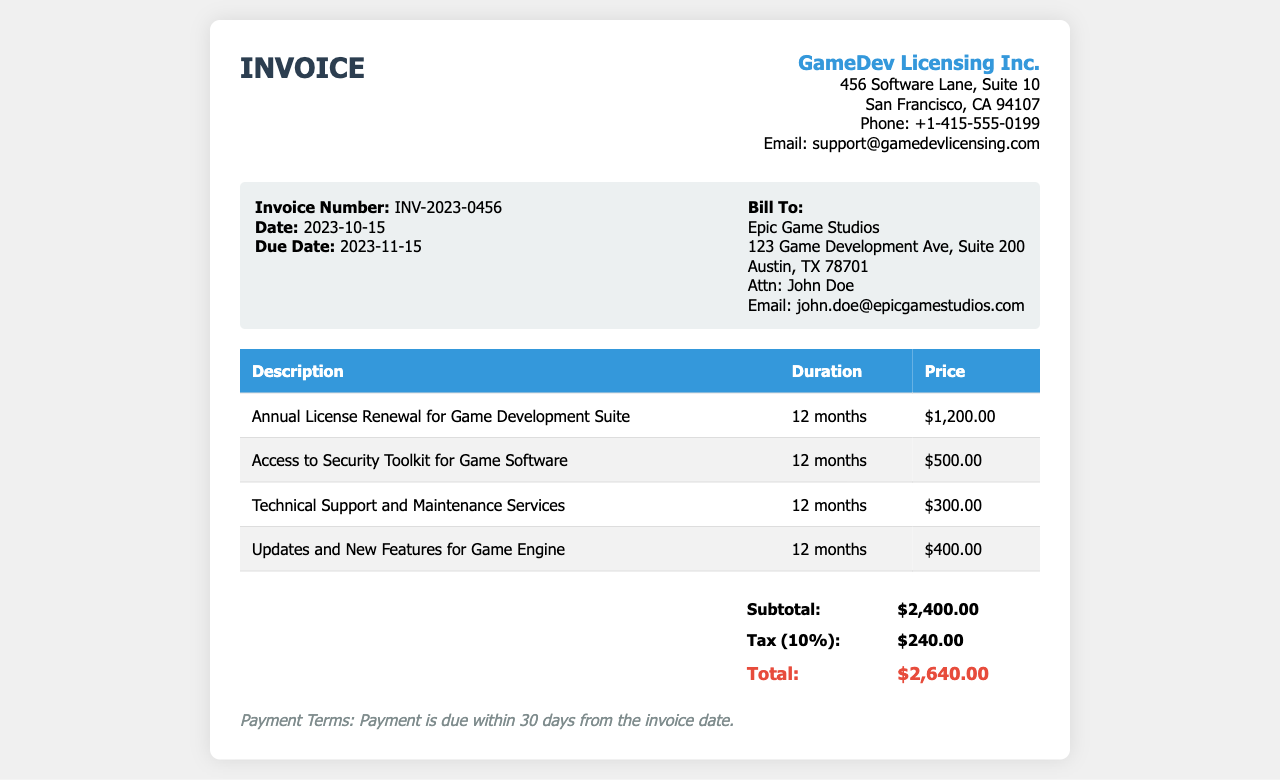What is the invoice number? The invoice number is specifically mentioned in the document as INV-2023-0456.
Answer: INV-2023-0456 Who is the bill to? The bill is addressed to Epic Game Studios according to the invoice details.
Answer: Epic Game Studios What is the total amount due? The total amount due is calculated as the subtotal plus tax, which totals to $2,640.00.
Answer: $2,640.00 What is included in the annual license renewal? The invoice details mention an Annual License Renewal for Game Development Suite among other services.
Answer: Annual License Renewal for Game Development Suite How long is the license valid for? The duration for the license is explicitly stated as 12 months in the document.
Answer: 12 months What are the payment terms? The payment terms are stated clearly at the end of the invoice as payment due within 30 days from the invoice date.
Answer: Payment is due within 30 days from the invoice date What is the subtotal amount? The subtotal amount is provided before tax, which is $2,400.00 in the invoice.
Answer: $2,400.00 What is the tax percentage applied? The document specifies a tax of 10% on the subtotal amount.
Answer: 10% What services are covered under Technical Support? The invoice mentions Technical Support and Maintenance Services specifically as part of the renewal.
Answer: Technical Support and Maintenance Services 